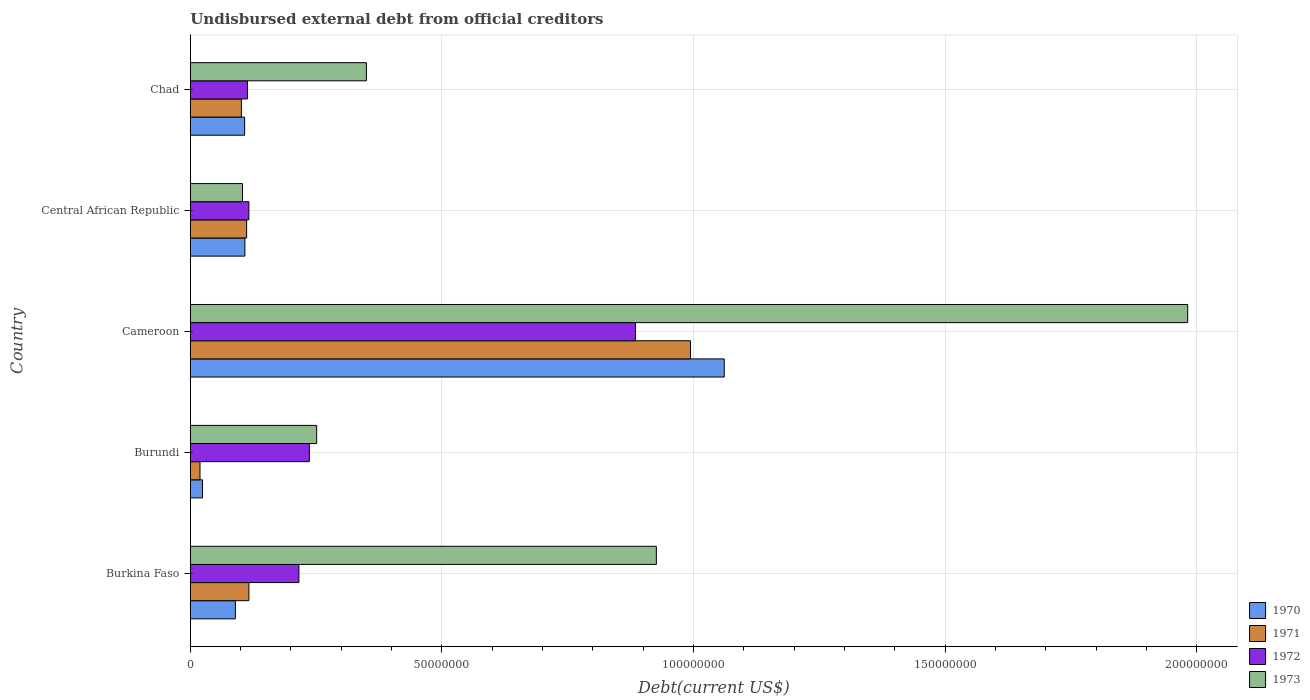How many different coloured bars are there?
Your answer should be very brief. 4. How many groups of bars are there?
Your answer should be compact. 5. How many bars are there on the 2nd tick from the top?
Offer a terse response. 4. How many bars are there on the 1st tick from the bottom?
Keep it short and to the point. 4. What is the label of the 1st group of bars from the top?
Give a very brief answer. Chad. What is the total debt in 1971 in Central African Republic?
Ensure brevity in your answer.  1.12e+07. Across all countries, what is the maximum total debt in 1972?
Keep it short and to the point. 8.84e+07. Across all countries, what is the minimum total debt in 1970?
Offer a terse response. 2.42e+06. In which country was the total debt in 1972 maximum?
Provide a succinct answer. Cameroon. In which country was the total debt in 1972 minimum?
Provide a succinct answer. Chad. What is the total total debt in 1971 in the graph?
Offer a very short reply. 1.34e+08. What is the difference between the total debt in 1972 in Burundi and that in Cameroon?
Make the answer very short. -6.48e+07. What is the difference between the total debt in 1973 in Burundi and the total debt in 1972 in Central African Republic?
Give a very brief answer. 1.35e+07. What is the average total debt in 1972 per country?
Give a very brief answer. 3.13e+07. What is the difference between the total debt in 1971 and total debt in 1970 in Cameroon?
Make the answer very short. -6.72e+06. What is the ratio of the total debt in 1973 in Burundi to that in Cameroon?
Keep it short and to the point. 0.13. What is the difference between the highest and the second highest total debt in 1973?
Offer a terse response. 1.06e+08. What is the difference between the highest and the lowest total debt in 1972?
Ensure brevity in your answer.  7.71e+07. Is the sum of the total debt in 1973 in Central African Republic and Chad greater than the maximum total debt in 1972 across all countries?
Your answer should be compact. No. Are all the bars in the graph horizontal?
Offer a very short reply. Yes. What is the difference between two consecutive major ticks on the X-axis?
Ensure brevity in your answer.  5.00e+07. Does the graph contain grids?
Provide a short and direct response. Yes. What is the title of the graph?
Ensure brevity in your answer.  Undisbursed external debt from official creditors. Does "1978" appear as one of the legend labels in the graph?
Your answer should be very brief. No. What is the label or title of the X-axis?
Your answer should be compact. Debt(current US$). What is the Debt(current US$) in 1970 in Burkina Faso?
Make the answer very short. 8.96e+06. What is the Debt(current US$) in 1971 in Burkina Faso?
Ensure brevity in your answer.  1.16e+07. What is the Debt(current US$) of 1972 in Burkina Faso?
Your response must be concise. 2.16e+07. What is the Debt(current US$) of 1973 in Burkina Faso?
Your response must be concise. 9.26e+07. What is the Debt(current US$) of 1970 in Burundi?
Make the answer very short. 2.42e+06. What is the Debt(current US$) of 1971 in Burundi?
Provide a succinct answer. 1.93e+06. What is the Debt(current US$) of 1972 in Burundi?
Your response must be concise. 2.37e+07. What is the Debt(current US$) of 1973 in Burundi?
Provide a short and direct response. 2.51e+07. What is the Debt(current US$) in 1970 in Cameroon?
Offer a very short reply. 1.06e+08. What is the Debt(current US$) of 1971 in Cameroon?
Provide a short and direct response. 9.94e+07. What is the Debt(current US$) of 1972 in Cameroon?
Ensure brevity in your answer.  8.84e+07. What is the Debt(current US$) of 1973 in Cameroon?
Give a very brief answer. 1.98e+08. What is the Debt(current US$) in 1970 in Central African Republic?
Give a very brief answer. 1.08e+07. What is the Debt(current US$) of 1971 in Central African Republic?
Give a very brief answer. 1.12e+07. What is the Debt(current US$) in 1972 in Central African Republic?
Your answer should be very brief. 1.16e+07. What is the Debt(current US$) of 1973 in Central African Republic?
Provide a short and direct response. 1.04e+07. What is the Debt(current US$) of 1970 in Chad?
Offer a very short reply. 1.08e+07. What is the Debt(current US$) of 1971 in Chad?
Keep it short and to the point. 1.02e+07. What is the Debt(current US$) in 1972 in Chad?
Give a very brief answer. 1.14e+07. What is the Debt(current US$) in 1973 in Chad?
Offer a terse response. 3.50e+07. Across all countries, what is the maximum Debt(current US$) in 1970?
Provide a short and direct response. 1.06e+08. Across all countries, what is the maximum Debt(current US$) of 1971?
Offer a terse response. 9.94e+07. Across all countries, what is the maximum Debt(current US$) in 1972?
Ensure brevity in your answer.  8.84e+07. Across all countries, what is the maximum Debt(current US$) of 1973?
Ensure brevity in your answer.  1.98e+08. Across all countries, what is the minimum Debt(current US$) in 1970?
Make the answer very short. 2.42e+06. Across all countries, what is the minimum Debt(current US$) of 1971?
Make the answer very short. 1.93e+06. Across all countries, what is the minimum Debt(current US$) in 1972?
Your answer should be very brief. 1.14e+07. Across all countries, what is the minimum Debt(current US$) in 1973?
Your response must be concise. 1.04e+07. What is the total Debt(current US$) in 1970 in the graph?
Offer a terse response. 1.39e+08. What is the total Debt(current US$) in 1971 in the graph?
Your response must be concise. 1.34e+08. What is the total Debt(current US$) of 1972 in the graph?
Offer a terse response. 1.57e+08. What is the total Debt(current US$) in 1973 in the graph?
Keep it short and to the point. 3.61e+08. What is the difference between the Debt(current US$) in 1970 in Burkina Faso and that in Burundi?
Give a very brief answer. 6.54e+06. What is the difference between the Debt(current US$) of 1971 in Burkina Faso and that in Burundi?
Your answer should be very brief. 9.71e+06. What is the difference between the Debt(current US$) of 1972 in Burkina Faso and that in Burundi?
Make the answer very short. -2.08e+06. What is the difference between the Debt(current US$) of 1973 in Burkina Faso and that in Burundi?
Make the answer very short. 6.75e+07. What is the difference between the Debt(current US$) in 1970 in Burkina Faso and that in Cameroon?
Your response must be concise. -9.71e+07. What is the difference between the Debt(current US$) in 1971 in Burkina Faso and that in Cameroon?
Make the answer very short. -8.77e+07. What is the difference between the Debt(current US$) in 1972 in Burkina Faso and that in Cameroon?
Provide a short and direct response. -6.69e+07. What is the difference between the Debt(current US$) in 1973 in Burkina Faso and that in Cameroon?
Keep it short and to the point. -1.06e+08. What is the difference between the Debt(current US$) in 1970 in Burkina Faso and that in Central African Republic?
Offer a very short reply. -1.89e+06. What is the difference between the Debt(current US$) in 1971 in Burkina Faso and that in Central African Republic?
Offer a very short reply. 4.50e+05. What is the difference between the Debt(current US$) of 1972 in Burkina Faso and that in Central African Republic?
Ensure brevity in your answer.  9.94e+06. What is the difference between the Debt(current US$) of 1973 in Burkina Faso and that in Central African Republic?
Your response must be concise. 8.22e+07. What is the difference between the Debt(current US$) of 1970 in Burkina Faso and that in Chad?
Offer a terse response. -1.83e+06. What is the difference between the Debt(current US$) in 1971 in Burkina Faso and that in Chad?
Ensure brevity in your answer.  1.49e+06. What is the difference between the Debt(current US$) in 1972 in Burkina Faso and that in Chad?
Your response must be concise. 1.02e+07. What is the difference between the Debt(current US$) of 1973 in Burkina Faso and that in Chad?
Keep it short and to the point. 5.76e+07. What is the difference between the Debt(current US$) of 1970 in Burundi and that in Cameroon?
Provide a short and direct response. -1.04e+08. What is the difference between the Debt(current US$) in 1971 in Burundi and that in Cameroon?
Your answer should be very brief. -9.74e+07. What is the difference between the Debt(current US$) of 1972 in Burundi and that in Cameroon?
Make the answer very short. -6.48e+07. What is the difference between the Debt(current US$) of 1973 in Burundi and that in Cameroon?
Ensure brevity in your answer.  -1.73e+08. What is the difference between the Debt(current US$) in 1970 in Burundi and that in Central African Republic?
Offer a terse response. -8.42e+06. What is the difference between the Debt(current US$) in 1971 in Burundi and that in Central African Republic?
Provide a short and direct response. -9.26e+06. What is the difference between the Debt(current US$) of 1972 in Burundi and that in Central African Republic?
Provide a succinct answer. 1.20e+07. What is the difference between the Debt(current US$) in 1973 in Burundi and that in Central African Republic?
Provide a short and direct response. 1.47e+07. What is the difference between the Debt(current US$) of 1970 in Burundi and that in Chad?
Make the answer very short. -8.37e+06. What is the difference between the Debt(current US$) in 1971 in Burundi and that in Chad?
Provide a succinct answer. -8.22e+06. What is the difference between the Debt(current US$) in 1972 in Burundi and that in Chad?
Keep it short and to the point. 1.23e+07. What is the difference between the Debt(current US$) of 1973 in Burundi and that in Chad?
Your answer should be very brief. -9.88e+06. What is the difference between the Debt(current US$) in 1970 in Cameroon and that in Central African Republic?
Ensure brevity in your answer.  9.52e+07. What is the difference between the Debt(current US$) of 1971 in Cameroon and that in Central African Republic?
Provide a short and direct response. 8.82e+07. What is the difference between the Debt(current US$) in 1972 in Cameroon and that in Central African Republic?
Give a very brief answer. 7.68e+07. What is the difference between the Debt(current US$) of 1973 in Cameroon and that in Central African Republic?
Ensure brevity in your answer.  1.88e+08. What is the difference between the Debt(current US$) of 1970 in Cameroon and that in Chad?
Give a very brief answer. 9.53e+07. What is the difference between the Debt(current US$) in 1971 in Cameroon and that in Chad?
Give a very brief answer. 8.92e+07. What is the difference between the Debt(current US$) in 1972 in Cameroon and that in Chad?
Provide a short and direct response. 7.71e+07. What is the difference between the Debt(current US$) of 1973 in Cameroon and that in Chad?
Provide a short and direct response. 1.63e+08. What is the difference between the Debt(current US$) of 1970 in Central African Republic and that in Chad?
Your answer should be very brief. 5.50e+04. What is the difference between the Debt(current US$) in 1971 in Central African Republic and that in Chad?
Make the answer very short. 1.04e+06. What is the difference between the Debt(current US$) in 1972 in Central African Republic and that in Chad?
Provide a short and direct response. 2.79e+05. What is the difference between the Debt(current US$) of 1973 in Central African Republic and that in Chad?
Provide a short and direct response. -2.46e+07. What is the difference between the Debt(current US$) of 1970 in Burkina Faso and the Debt(current US$) of 1971 in Burundi?
Provide a short and direct response. 7.03e+06. What is the difference between the Debt(current US$) in 1970 in Burkina Faso and the Debt(current US$) in 1972 in Burundi?
Your answer should be very brief. -1.47e+07. What is the difference between the Debt(current US$) of 1970 in Burkina Faso and the Debt(current US$) of 1973 in Burundi?
Give a very brief answer. -1.62e+07. What is the difference between the Debt(current US$) of 1971 in Burkina Faso and the Debt(current US$) of 1972 in Burundi?
Offer a very short reply. -1.20e+07. What is the difference between the Debt(current US$) of 1971 in Burkina Faso and the Debt(current US$) of 1973 in Burundi?
Offer a terse response. -1.35e+07. What is the difference between the Debt(current US$) of 1972 in Burkina Faso and the Debt(current US$) of 1973 in Burundi?
Provide a succinct answer. -3.53e+06. What is the difference between the Debt(current US$) of 1970 in Burkina Faso and the Debt(current US$) of 1971 in Cameroon?
Offer a terse response. -9.04e+07. What is the difference between the Debt(current US$) in 1970 in Burkina Faso and the Debt(current US$) in 1972 in Cameroon?
Give a very brief answer. -7.95e+07. What is the difference between the Debt(current US$) in 1970 in Burkina Faso and the Debt(current US$) in 1973 in Cameroon?
Make the answer very short. -1.89e+08. What is the difference between the Debt(current US$) of 1971 in Burkina Faso and the Debt(current US$) of 1972 in Cameroon?
Keep it short and to the point. -7.68e+07. What is the difference between the Debt(current US$) of 1971 in Burkina Faso and the Debt(current US$) of 1973 in Cameroon?
Make the answer very short. -1.87e+08. What is the difference between the Debt(current US$) in 1972 in Burkina Faso and the Debt(current US$) in 1973 in Cameroon?
Provide a short and direct response. -1.77e+08. What is the difference between the Debt(current US$) in 1970 in Burkina Faso and the Debt(current US$) in 1971 in Central African Republic?
Give a very brief answer. -2.23e+06. What is the difference between the Debt(current US$) in 1970 in Burkina Faso and the Debt(current US$) in 1972 in Central African Republic?
Ensure brevity in your answer.  -2.68e+06. What is the difference between the Debt(current US$) in 1970 in Burkina Faso and the Debt(current US$) in 1973 in Central African Republic?
Your response must be concise. -1.41e+06. What is the difference between the Debt(current US$) in 1971 in Burkina Faso and the Debt(current US$) in 1972 in Central African Republic?
Provide a succinct answer. 6000. What is the difference between the Debt(current US$) of 1971 in Burkina Faso and the Debt(current US$) of 1973 in Central African Republic?
Your answer should be compact. 1.27e+06. What is the difference between the Debt(current US$) in 1972 in Burkina Faso and the Debt(current US$) in 1973 in Central African Republic?
Offer a terse response. 1.12e+07. What is the difference between the Debt(current US$) in 1970 in Burkina Faso and the Debt(current US$) in 1971 in Chad?
Provide a succinct answer. -1.19e+06. What is the difference between the Debt(current US$) in 1970 in Burkina Faso and the Debt(current US$) in 1972 in Chad?
Offer a very short reply. -2.40e+06. What is the difference between the Debt(current US$) in 1970 in Burkina Faso and the Debt(current US$) in 1973 in Chad?
Offer a terse response. -2.60e+07. What is the difference between the Debt(current US$) in 1971 in Burkina Faso and the Debt(current US$) in 1972 in Chad?
Your response must be concise. 2.85e+05. What is the difference between the Debt(current US$) of 1971 in Burkina Faso and the Debt(current US$) of 1973 in Chad?
Provide a succinct answer. -2.33e+07. What is the difference between the Debt(current US$) of 1972 in Burkina Faso and the Debt(current US$) of 1973 in Chad?
Your answer should be compact. -1.34e+07. What is the difference between the Debt(current US$) in 1970 in Burundi and the Debt(current US$) in 1971 in Cameroon?
Ensure brevity in your answer.  -9.69e+07. What is the difference between the Debt(current US$) of 1970 in Burundi and the Debt(current US$) of 1972 in Cameroon?
Keep it short and to the point. -8.60e+07. What is the difference between the Debt(current US$) of 1970 in Burundi and the Debt(current US$) of 1973 in Cameroon?
Provide a short and direct response. -1.96e+08. What is the difference between the Debt(current US$) of 1971 in Burundi and the Debt(current US$) of 1972 in Cameroon?
Make the answer very short. -8.65e+07. What is the difference between the Debt(current US$) in 1971 in Burundi and the Debt(current US$) in 1973 in Cameroon?
Offer a very short reply. -1.96e+08. What is the difference between the Debt(current US$) in 1972 in Burundi and the Debt(current US$) in 1973 in Cameroon?
Offer a terse response. -1.75e+08. What is the difference between the Debt(current US$) in 1970 in Burundi and the Debt(current US$) in 1971 in Central African Republic?
Provide a short and direct response. -8.77e+06. What is the difference between the Debt(current US$) in 1970 in Burundi and the Debt(current US$) in 1972 in Central African Republic?
Offer a terse response. -9.21e+06. What is the difference between the Debt(current US$) of 1970 in Burundi and the Debt(current US$) of 1973 in Central African Republic?
Offer a very short reply. -7.94e+06. What is the difference between the Debt(current US$) of 1971 in Burundi and the Debt(current US$) of 1972 in Central African Republic?
Offer a terse response. -9.71e+06. What is the difference between the Debt(current US$) of 1971 in Burundi and the Debt(current US$) of 1973 in Central African Republic?
Provide a succinct answer. -8.44e+06. What is the difference between the Debt(current US$) of 1972 in Burundi and the Debt(current US$) of 1973 in Central African Republic?
Keep it short and to the point. 1.33e+07. What is the difference between the Debt(current US$) in 1970 in Burundi and the Debt(current US$) in 1971 in Chad?
Provide a succinct answer. -7.73e+06. What is the difference between the Debt(current US$) of 1970 in Burundi and the Debt(current US$) of 1972 in Chad?
Provide a short and direct response. -8.93e+06. What is the difference between the Debt(current US$) of 1970 in Burundi and the Debt(current US$) of 1973 in Chad?
Your response must be concise. -3.26e+07. What is the difference between the Debt(current US$) in 1971 in Burundi and the Debt(current US$) in 1972 in Chad?
Provide a short and direct response. -9.43e+06. What is the difference between the Debt(current US$) in 1971 in Burundi and the Debt(current US$) in 1973 in Chad?
Make the answer very short. -3.31e+07. What is the difference between the Debt(current US$) of 1972 in Burundi and the Debt(current US$) of 1973 in Chad?
Your answer should be very brief. -1.13e+07. What is the difference between the Debt(current US$) in 1970 in Cameroon and the Debt(current US$) in 1971 in Central African Republic?
Offer a terse response. 9.49e+07. What is the difference between the Debt(current US$) in 1970 in Cameroon and the Debt(current US$) in 1972 in Central African Republic?
Keep it short and to the point. 9.45e+07. What is the difference between the Debt(current US$) of 1970 in Cameroon and the Debt(current US$) of 1973 in Central African Republic?
Your answer should be compact. 9.57e+07. What is the difference between the Debt(current US$) of 1971 in Cameroon and the Debt(current US$) of 1972 in Central African Republic?
Ensure brevity in your answer.  8.77e+07. What is the difference between the Debt(current US$) of 1971 in Cameroon and the Debt(current US$) of 1973 in Central African Republic?
Offer a very short reply. 8.90e+07. What is the difference between the Debt(current US$) of 1972 in Cameroon and the Debt(current US$) of 1973 in Central African Republic?
Your answer should be very brief. 7.81e+07. What is the difference between the Debt(current US$) in 1970 in Cameroon and the Debt(current US$) in 1971 in Chad?
Give a very brief answer. 9.59e+07. What is the difference between the Debt(current US$) in 1970 in Cameroon and the Debt(current US$) in 1972 in Chad?
Offer a terse response. 9.47e+07. What is the difference between the Debt(current US$) in 1970 in Cameroon and the Debt(current US$) in 1973 in Chad?
Ensure brevity in your answer.  7.11e+07. What is the difference between the Debt(current US$) of 1971 in Cameroon and the Debt(current US$) of 1972 in Chad?
Give a very brief answer. 8.80e+07. What is the difference between the Debt(current US$) in 1971 in Cameroon and the Debt(current US$) in 1973 in Chad?
Keep it short and to the point. 6.44e+07. What is the difference between the Debt(current US$) in 1972 in Cameroon and the Debt(current US$) in 1973 in Chad?
Ensure brevity in your answer.  5.35e+07. What is the difference between the Debt(current US$) of 1970 in Central African Republic and the Debt(current US$) of 1971 in Chad?
Provide a short and direct response. 6.94e+05. What is the difference between the Debt(current US$) of 1970 in Central African Republic and the Debt(current US$) of 1972 in Chad?
Offer a very short reply. -5.09e+05. What is the difference between the Debt(current US$) of 1970 in Central African Republic and the Debt(current US$) of 1973 in Chad?
Offer a very short reply. -2.41e+07. What is the difference between the Debt(current US$) in 1971 in Central African Republic and the Debt(current US$) in 1972 in Chad?
Provide a succinct answer. -1.65e+05. What is the difference between the Debt(current US$) in 1971 in Central African Republic and the Debt(current US$) in 1973 in Chad?
Offer a terse response. -2.38e+07. What is the difference between the Debt(current US$) in 1972 in Central African Republic and the Debt(current US$) in 1973 in Chad?
Keep it short and to the point. -2.34e+07. What is the average Debt(current US$) in 1970 per country?
Provide a succinct answer. 2.78e+07. What is the average Debt(current US$) in 1971 per country?
Make the answer very short. 2.69e+07. What is the average Debt(current US$) of 1972 per country?
Your answer should be compact. 3.13e+07. What is the average Debt(current US$) of 1973 per country?
Give a very brief answer. 7.22e+07. What is the difference between the Debt(current US$) of 1970 and Debt(current US$) of 1971 in Burkina Faso?
Make the answer very short. -2.68e+06. What is the difference between the Debt(current US$) of 1970 and Debt(current US$) of 1972 in Burkina Faso?
Provide a succinct answer. -1.26e+07. What is the difference between the Debt(current US$) in 1970 and Debt(current US$) in 1973 in Burkina Faso?
Offer a terse response. -8.36e+07. What is the difference between the Debt(current US$) of 1971 and Debt(current US$) of 1972 in Burkina Faso?
Make the answer very short. -9.93e+06. What is the difference between the Debt(current US$) of 1971 and Debt(current US$) of 1973 in Burkina Faso?
Offer a terse response. -8.10e+07. What is the difference between the Debt(current US$) in 1972 and Debt(current US$) in 1973 in Burkina Faso?
Give a very brief answer. -7.10e+07. What is the difference between the Debt(current US$) in 1970 and Debt(current US$) in 1971 in Burundi?
Your response must be concise. 4.96e+05. What is the difference between the Debt(current US$) of 1970 and Debt(current US$) of 1972 in Burundi?
Keep it short and to the point. -2.12e+07. What is the difference between the Debt(current US$) of 1970 and Debt(current US$) of 1973 in Burundi?
Provide a short and direct response. -2.27e+07. What is the difference between the Debt(current US$) in 1971 and Debt(current US$) in 1972 in Burundi?
Provide a short and direct response. -2.17e+07. What is the difference between the Debt(current US$) in 1971 and Debt(current US$) in 1973 in Burundi?
Make the answer very short. -2.32e+07. What is the difference between the Debt(current US$) of 1972 and Debt(current US$) of 1973 in Burundi?
Your answer should be compact. -1.45e+06. What is the difference between the Debt(current US$) in 1970 and Debt(current US$) in 1971 in Cameroon?
Offer a very short reply. 6.72e+06. What is the difference between the Debt(current US$) of 1970 and Debt(current US$) of 1972 in Cameroon?
Give a very brief answer. 1.76e+07. What is the difference between the Debt(current US$) of 1970 and Debt(current US$) of 1973 in Cameroon?
Provide a short and direct response. -9.21e+07. What is the difference between the Debt(current US$) in 1971 and Debt(current US$) in 1972 in Cameroon?
Offer a very short reply. 1.09e+07. What is the difference between the Debt(current US$) in 1971 and Debt(current US$) in 1973 in Cameroon?
Provide a succinct answer. -9.88e+07. What is the difference between the Debt(current US$) in 1972 and Debt(current US$) in 1973 in Cameroon?
Your answer should be very brief. -1.10e+08. What is the difference between the Debt(current US$) in 1970 and Debt(current US$) in 1971 in Central African Republic?
Provide a short and direct response. -3.44e+05. What is the difference between the Debt(current US$) of 1970 and Debt(current US$) of 1972 in Central African Republic?
Your answer should be compact. -7.88e+05. What is the difference between the Debt(current US$) in 1970 and Debt(current US$) in 1973 in Central African Republic?
Your response must be concise. 4.80e+05. What is the difference between the Debt(current US$) in 1971 and Debt(current US$) in 1972 in Central African Republic?
Offer a very short reply. -4.44e+05. What is the difference between the Debt(current US$) of 1971 and Debt(current US$) of 1973 in Central African Republic?
Ensure brevity in your answer.  8.24e+05. What is the difference between the Debt(current US$) of 1972 and Debt(current US$) of 1973 in Central African Republic?
Offer a very short reply. 1.27e+06. What is the difference between the Debt(current US$) of 1970 and Debt(current US$) of 1971 in Chad?
Make the answer very short. 6.39e+05. What is the difference between the Debt(current US$) of 1970 and Debt(current US$) of 1972 in Chad?
Keep it short and to the point. -5.64e+05. What is the difference between the Debt(current US$) of 1970 and Debt(current US$) of 1973 in Chad?
Provide a short and direct response. -2.42e+07. What is the difference between the Debt(current US$) of 1971 and Debt(current US$) of 1972 in Chad?
Provide a short and direct response. -1.20e+06. What is the difference between the Debt(current US$) in 1971 and Debt(current US$) in 1973 in Chad?
Offer a very short reply. -2.48e+07. What is the difference between the Debt(current US$) in 1972 and Debt(current US$) in 1973 in Chad?
Your answer should be very brief. -2.36e+07. What is the ratio of the Debt(current US$) of 1970 in Burkina Faso to that in Burundi?
Your response must be concise. 3.69. What is the ratio of the Debt(current US$) in 1971 in Burkina Faso to that in Burundi?
Give a very brief answer. 6.04. What is the ratio of the Debt(current US$) in 1972 in Burkina Faso to that in Burundi?
Offer a terse response. 0.91. What is the ratio of the Debt(current US$) of 1973 in Burkina Faso to that in Burundi?
Keep it short and to the point. 3.69. What is the ratio of the Debt(current US$) in 1970 in Burkina Faso to that in Cameroon?
Ensure brevity in your answer.  0.08. What is the ratio of the Debt(current US$) in 1971 in Burkina Faso to that in Cameroon?
Make the answer very short. 0.12. What is the ratio of the Debt(current US$) in 1972 in Burkina Faso to that in Cameroon?
Provide a succinct answer. 0.24. What is the ratio of the Debt(current US$) of 1973 in Burkina Faso to that in Cameroon?
Offer a very short reply. 0.47. What is the ratio of the Debt(current US$) in 1970 in Burkina Faso to that in Central African Republic?
Ensure brevity in your answer.  0.83. What is the ratio of the Debt(current US$) of 1971 in Burkina Faso to that in Central African Republic?
Provide a short and direct response. 1.04. What is the ratio of the Debt(current US$) in 1972 in Burkina Faso to that in Central African Republic?
Provide a short and direct response. 1.85. What is the ratio of the Debt(current US$) in 1973 in Burkina Faso to that in Central African Republic?
Give a very brief answer. 8.93. What is the ratio of the Debt(current US$) of 1970 in Burkina Faso to that in Chad?
Offer a very short reply. 0.83. What is the ratio of the Debt(current US$) in 1971 in Burkina Faso to that in Chad?
Offer a very short reply. 1.15. What is the ratio of the Debt(current US$) of 1972 in Burkina Faso to that in Chad?
Make the answer very short. 1.9. What is the ratio of the Debt(current US$) in 1973 in Burkina Faso to that in Chad?
Offer a terse response. 2.65. What is the ratio of the Debt(current US$) in 1970 in Burundi to that in Cameroon?
Your answer should be very brief. 0.02. What is the ratio of the Debt(current US$) of 1971 in Burundi to that in Cameroon?
Your answer should be compact. 0.02. What is the ratio of the Debt(current US$) of 1972 in Burundi to that in Cameroon?
Your answer should be compact. 0.27. What is the ratio of the Debt(current US$) of 1973 in Burundi to that in Cameroon?
Provide a succinct answer. 0.13. What is the ratio of the Debt(current US$) of 1970 in Burundi to that in Central African Republic?
Ensure brevity in your answer.  0.22. What is the ratio of the Debt(current US$) of 1971 in Burundi to that in Central African Republic?
Give a very brief answer. 0.17. What is the ratio of the Debt(current US$) of 1972 in Burundi to that in Central African Republic?
Your response must be concise. 2.03. What is the ratio of the Debt(current US$) in 1973 in Burundi to that in Central African Republic?
Keep it short and to the point. 2.42. What is the ratio of the Debt(current US$) of 1970 in Burundi to that in Chad?
Provide a succinct answer. 0.22. What is the ratio of the Debt(current US$) in 1971 in Burundi to that in Chad?
Offer a terse response. 0.19. What is the ratio of the Debt(current US$) of 1972 in Burundi to that in Chad?
Provide a short and direct response. 2.08. What is the ratio of the Debt(current US$) of 1973 in Burundi to that in Chad?
Your answer should be compact. 0.72. What is the ratio of the Debt(current US$) of 1970 in Cameroon to that in Central African Republic?
Give a very brief answer. 9.78. What is the ratio of the Debt(current US$) of 1971 in Cameroon to that in Central African Republic?
Offer a terse response. 8.88. What is the ratio of the Debt(current US$) of 1972 in Cameroon to that in Central African Republic?
Offer a terse response. 7.6. What is the ratio of the Debt(current US$) in 1973 in Cameroon to that in Central African Republic?
Your response must be concise. 19.11. What is the ratio of the Debt(current US$) of 1970 in Cameroon to that in Chad?
Your answer should be compact. 9.83. What is the ratio of the Debt(current US$) in 1971 in Cameroon to that in Chad?
Offer a terse response. 9.79. What is the ratio of the Debt(current US$) in 1972 in Cameroon to that in Chad?
Your answer should be compact. 7.79. What is the ratio of the Debt(current US$) of 1973 in Cameroon to that in Chad?
Your response must be concise. 5.66. What is the ratio of the Debt(current US$) in 1971 in Central African Republic to that in Chad?
Give a very brief answer. 1.1. What is the ratio of the Debt(current US$) in 1972 in Central African Republic to that in Chad?
Your answer should be very brief. 1.02. What is the ratio of the Debt(current US$) of 1973 in Central African Republic to that in Chad?
Make the answer very short. 0.3. What is the difference between the highest and the second highest Debt(current US$) of 1970?
Your answer should be very brief. 9.52e+07. What is the difference between the highest and the second highest Debt(current US$) in 1971?
Keep it short and to the point. 8.77e+07. What is the difference between the highest and the second highest Debt(current US$) in 1972?
Give a very brief answer. 6.48e+07. What is the difference between the highest and the second highest Debt(current US$) in 1973?
Offer a terse response. 1.06e+08. What is the difference between the highest and the lowest Debt(current US$) of 1970?
Provide a short and direct response. 1.04e+08. What is the difference between the highest and the lowest Debt(current US$) in 1971?
Your response must be concise. 9.74e+07. What is the difference between the highest and the lowest Debt(current US$) in 1972?
Provide a short and direct response. 7.71e+07. What is the difference between the highest and the lowest Debt(current US$) in 1973?
Your response must be concise. 1.88e+08. 